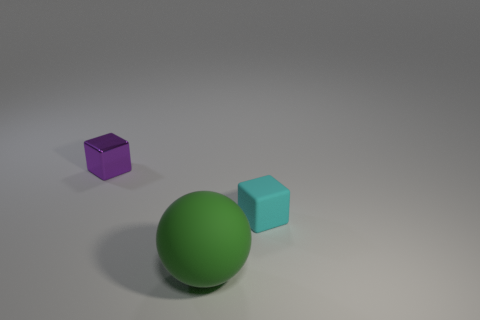Are there any other things of the same color as the ball?
Ensure brevity in your answer.  No. What is the block left of the large rubber object made of?
Provide a succinct answer. Metal. Do the cyan matte thing and the sphere have the same size?
Your answer should be very brief. No. How many other objects are the same size as the cyan block?
Your answer should be compact. 1. Is the big sphere the same color as the small matte cube?
Give a very brief answer. No. What is the shape of the rubber object that is on the left side of the tiny thing on the right side of the small thing behind the small rubber thing?
Provide a succinct answer. Sphere. What number of objects are either tiny objects behind the cyan object or tiny objects that are to the right of the big sphere?
Your answer should be compact. 2. What is the size of the purple cube behind the small object right of the green rubber object?
Provide a short and direct response. Small. There is a tiny block behind the rubber cube; is it the same color as the small rubber cube?
Provide a succinct answer. No. Are there any large matte things of the same shape as the tiny purple metallic object?
Your answer should be very brief. No. 